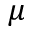<formula> <loc_0><loc_0><loc_500><loc_500>\mu</formula> 